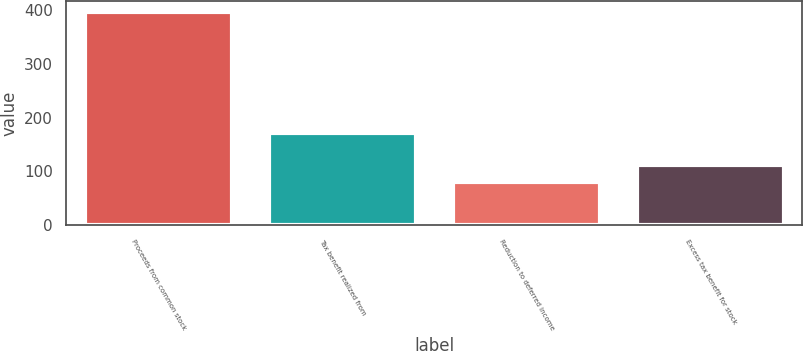Convert chart to OTSL. <chart><loc_0><loc_0><loc_500><loc_500><bar_chart><fcel>Proceeds from common stock<fcel>Tax benefit realized from<fcel>Reduction to deferred income<fcel>Excess tax benefit for stock<nl><fcel>396<fcel>171<fcel>81<fcel>112.5<nl></chart> 